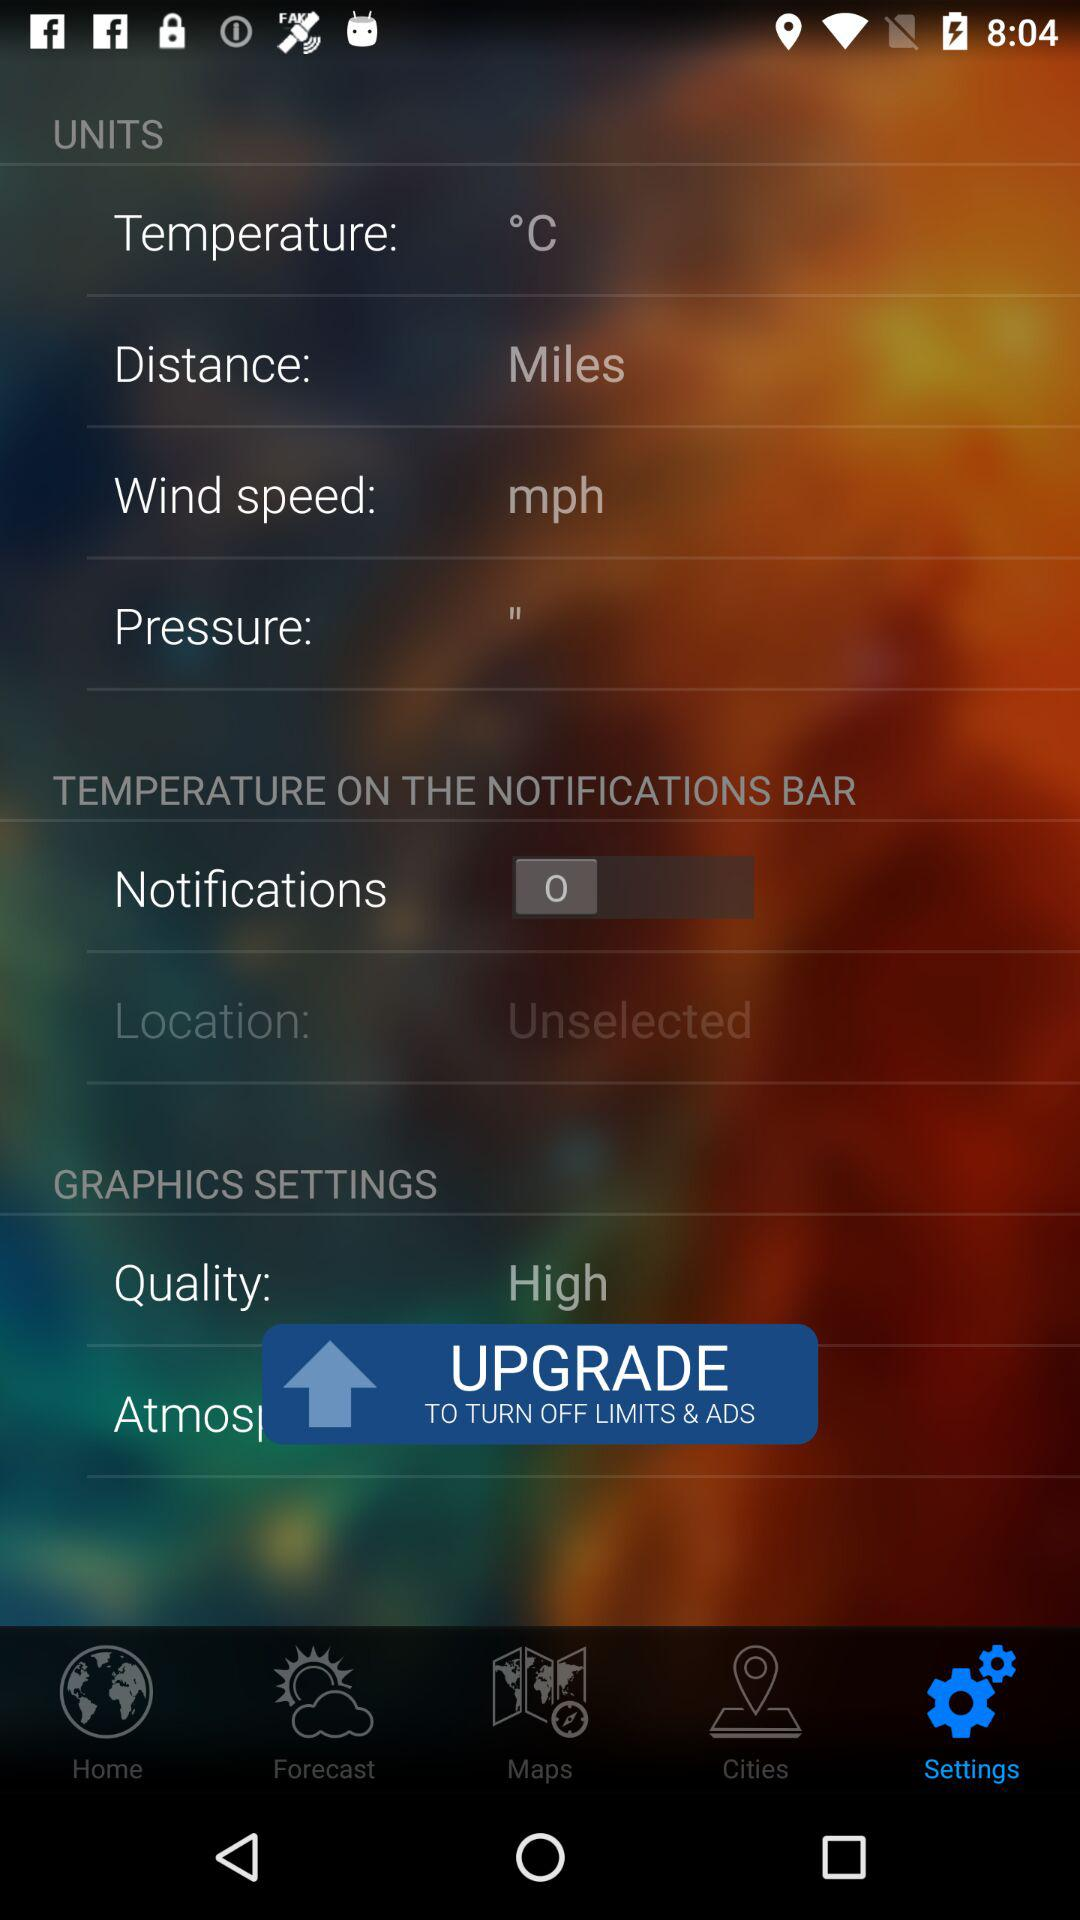What is the unit of temperature? The unit of temperature is degrees Celsius. 